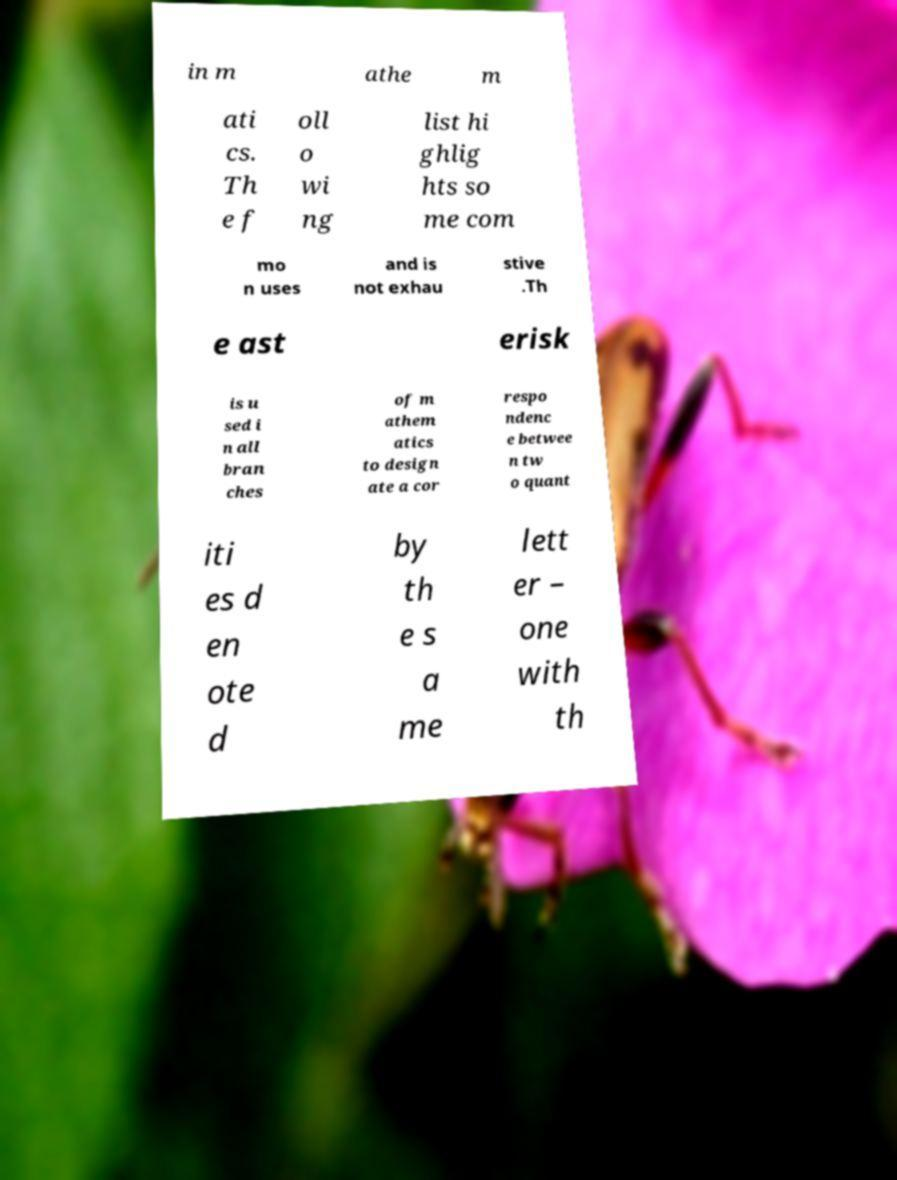There's text embedded in this image that I need extracted. Can you transcribe it verbatim? in m athe m ati cs. Th e f oll o wi ng list hi ghlig hts so me com mo n uses and is not exhau stive .Th e ast erisk is u sed i n all bran ches of m athem atics to design ate a cor respo ndenc e betwee n tw o quant iti es d en ote d by th e s a me lett er – one with th 